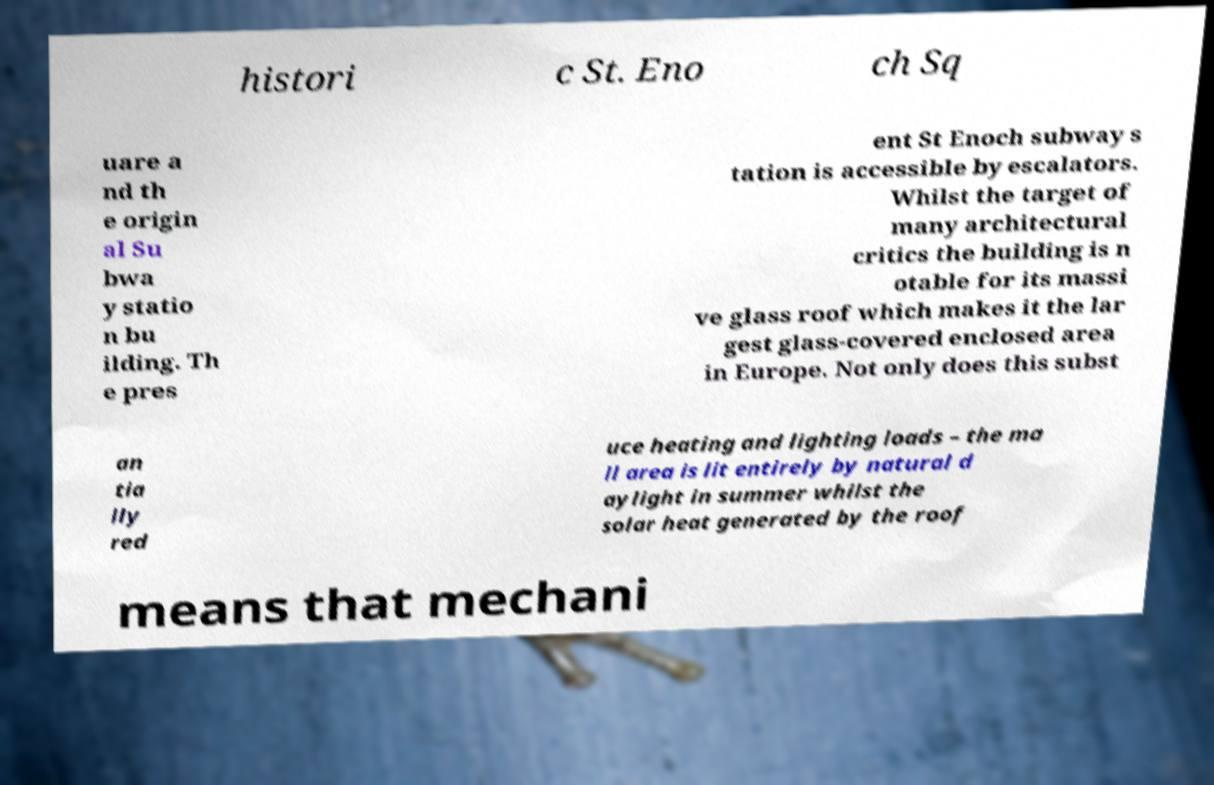Please identify and transcribe the text found in this image. histori c St. Eno ch Sq uare a nd th e origin al Su bwa y statio n bu ilding. Th e pres ent St Enoch subway s tation is accessible by escalators. Whilst the target of many architectural critics the building is n otable for its massi ve glass roof which makes it the lar gest glass-covered enclosed area in Europe. Not only does this subst an tia lly red uce heating and lighting loads – the ma ll area is lit entirely by natural d aylight in summer whilst the solar heat generated by the roof means that mechani 